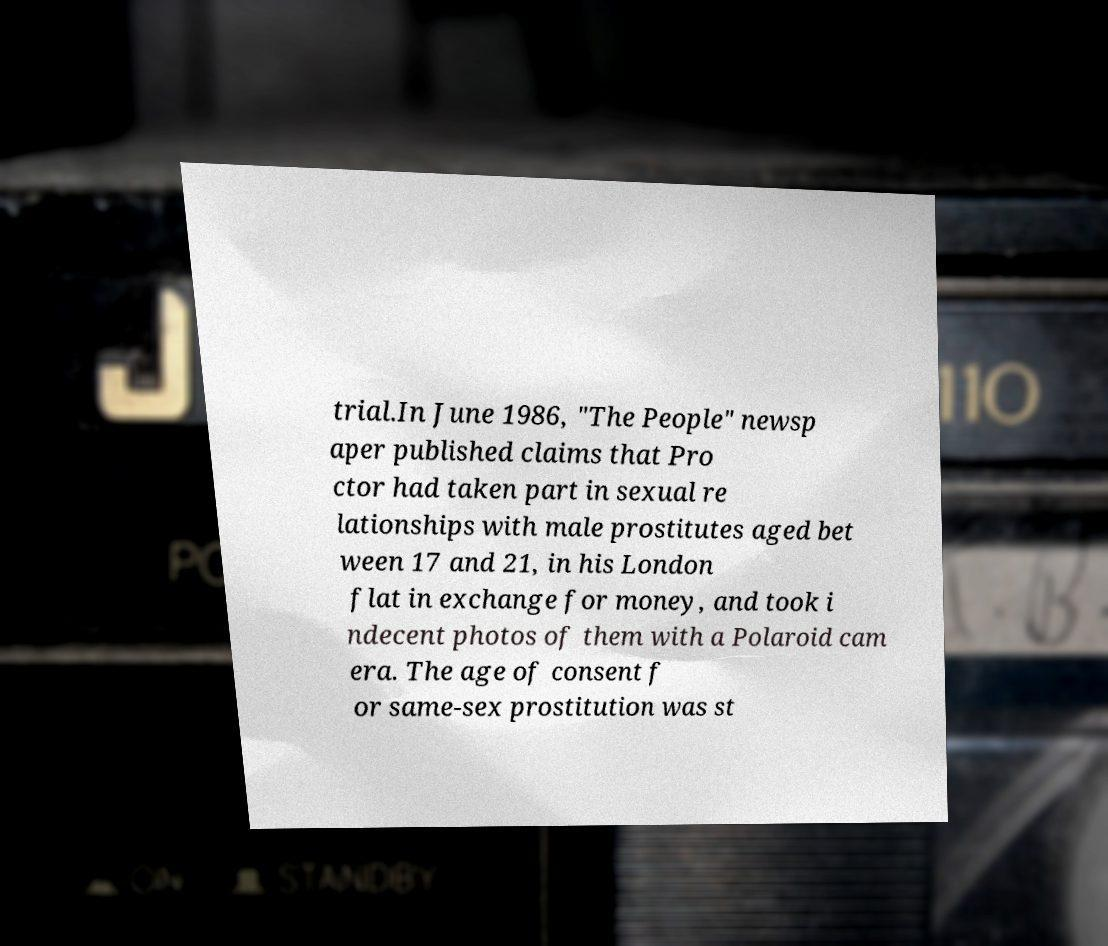Could you extract and type out the text from this image? trial.In June 1986, "The People" newsp aper published claims that Pro ctor had taken part in sexual re lationships with male prostitutes aged bet ween 17 and 21, in his London flat in exchange for money, and took i ndecent photos of them with a Polaroid cam era. The age of consent f or same-sex prostitution was st 